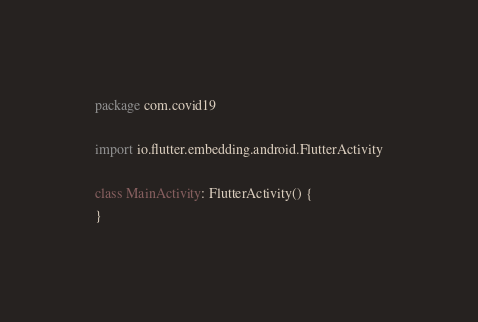<code> <loc_0><loc_0><loc_500><loc_500><_Kotlin_>package com.covid19

import io.flutter.embedding.android.FlutterActivity

class MainActivity: FlutterActivity() {
}
</code> 